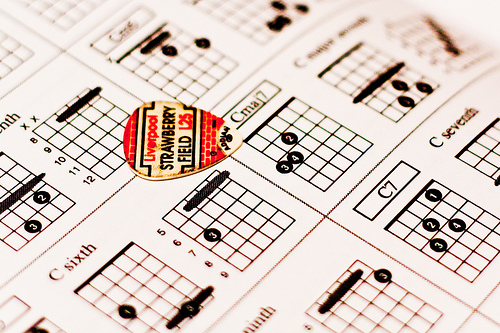<image>
Is there a grid under the guitar pick? No. The grid is not positioned under the guitar pick. The vertical relationship between these objects is different. 